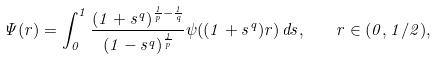Convert formula to latex. <formula><loc_0><loc_0><loc_500><loc_500>\Psi ( r ) = \int _ { 0 } ^ { 1 } \frac { ( 1 + s ^ { q } ) ^ { \frac { 1 } { p } - \frac { 1 } { q } } } { ( 1 - s ^ { q } ) ^ { \frac { 1 } { p } } } \psi ( ( 1 + s ^ { q } ) r ) \, d s , \quad r \in ( 0 , 1 / 2 ) ,</formula> 